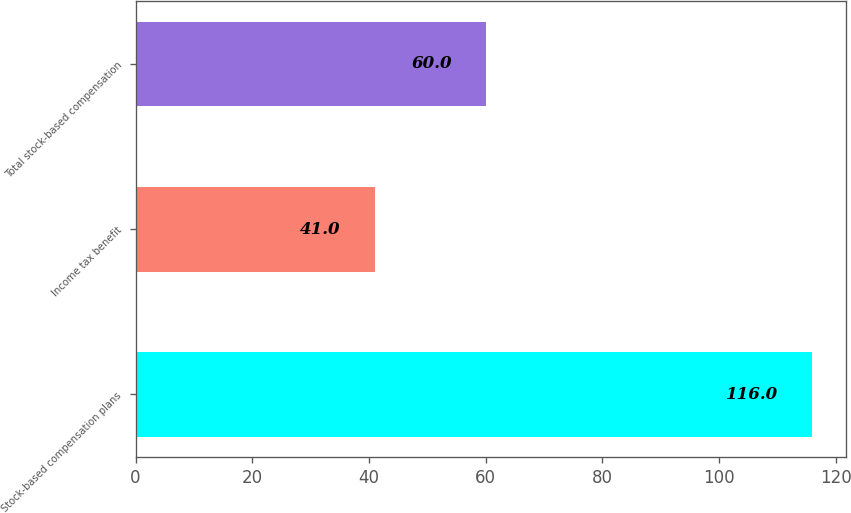Convert chart to OTSL. <chart><loc_0><loc_0><loc_500><loc_500><bar_chart><fcel>Stock-based compensation plans<fcel>Income tax benefit<fcel>Total stock-based compensation<nl><fcel>116<fcel>41<fcel>60<nl></chart> 